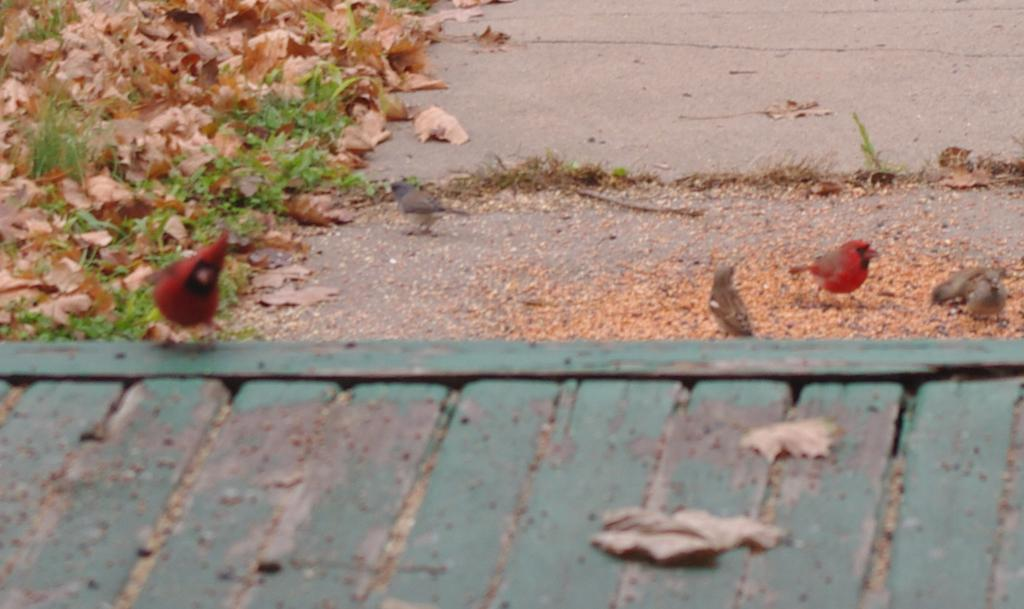What type of animals can be seen in the image? There are birds in the image. What structure is visible at the bottom of the image? There appears to be a roof at the bottom of the image. What type of natural debris can be seen on the road in the image? Dried leaves are visible on the road in the image. What language is being spoken by the birds in the image? There is no indication in the image that the birds are speaking any language. What type of feast is being prepared in the image? There is no feast or any indication of food preparation in the image. 